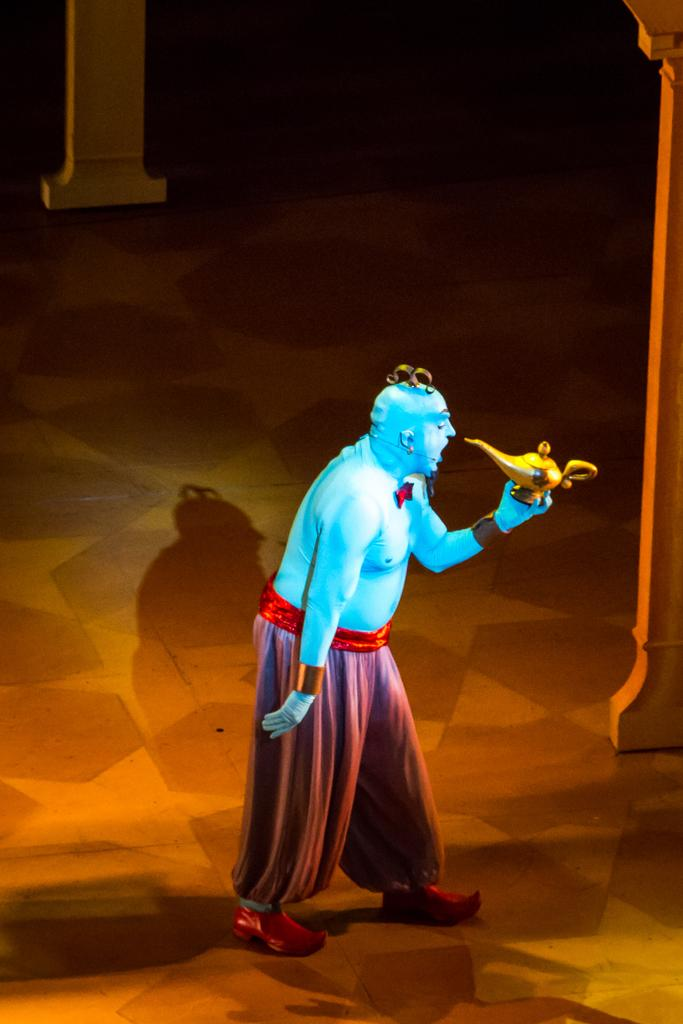What is the person in the image wearing? The person is wearing a costume in the image. What is the person holding in the image? The person is holding an object in the image. What type of surface is visible in the image? There is ground visible in the image. What architectural features can be seen in the image? There are pillars in the image. What type of fang can be seen in the image? There is no fang present in the image. 